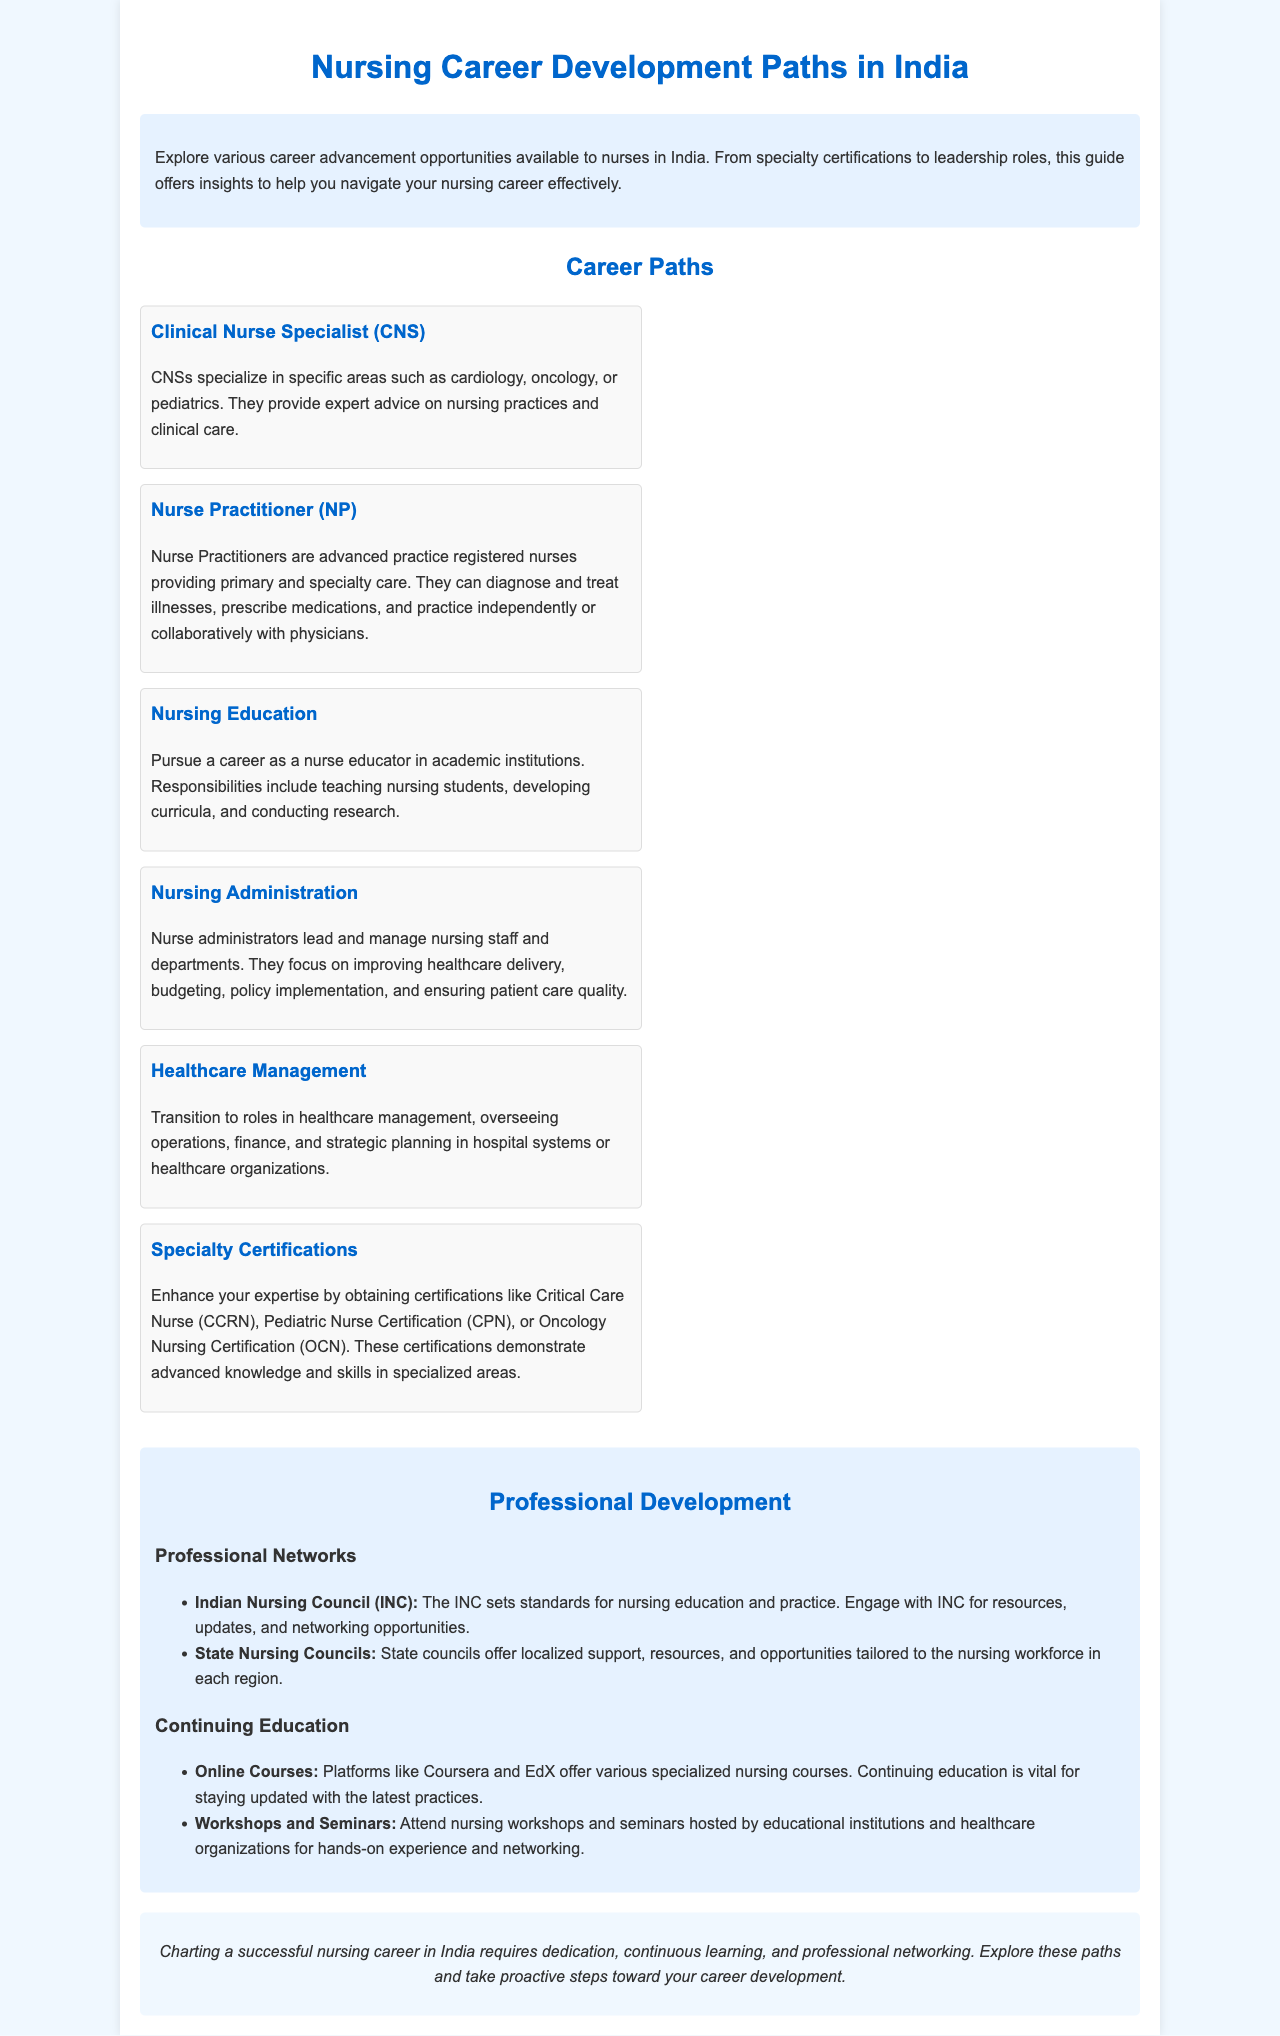What is the title of the document? The title of the document is found in the header section, indicating the main subject of the brochure.
Answer: Nursing Career Development Paths in India What are the names of two specialty certifications mentioned? The document includes specific certifications under the Specialty Certifications section.
Answer: Critical Care Nurse (CCRN), Pediatric Nurse Certification (CPN) What role do Nurse Practitioners hold? The document explicitly describes the responsibilities of Nurse Practitioners, highlighting their practice scope.
Answer: Primary and specialty care How many career paths are listed in the document? The document enumerates the different career paths available to nurses, providing an overview of available options.
Answer: Six Which professional network is responsible for setting standards for nursing education and practice? This information is under the Professional Networks section, detailing the roles of different nursing councils.
Answer: Indian Nursing Council (INC) What is one type of continuing education mentioned? The document specifies various continuing education options that nurses can pursue for professional development.
Answer: Online Courses What is the purpose of obtaining specialty certifications according to the document? The document explains the significance of certifications towards enhancing expertise and demonstrating advanced knowledge in specialized areas.
Answer: Demonstrate advanced knowledge and skills Which section follows the Career Paths section? The structure of the document organizes content thematically, helping to understand the progression of topics covered.
Answer: Professional Development What does the conclusion emphasize for a successful nursing career? The conclusion summarises the key elements to advancing in a nursing career outlined earlier in the document.
Answer: Dedication, continuous learning, and professional networking 